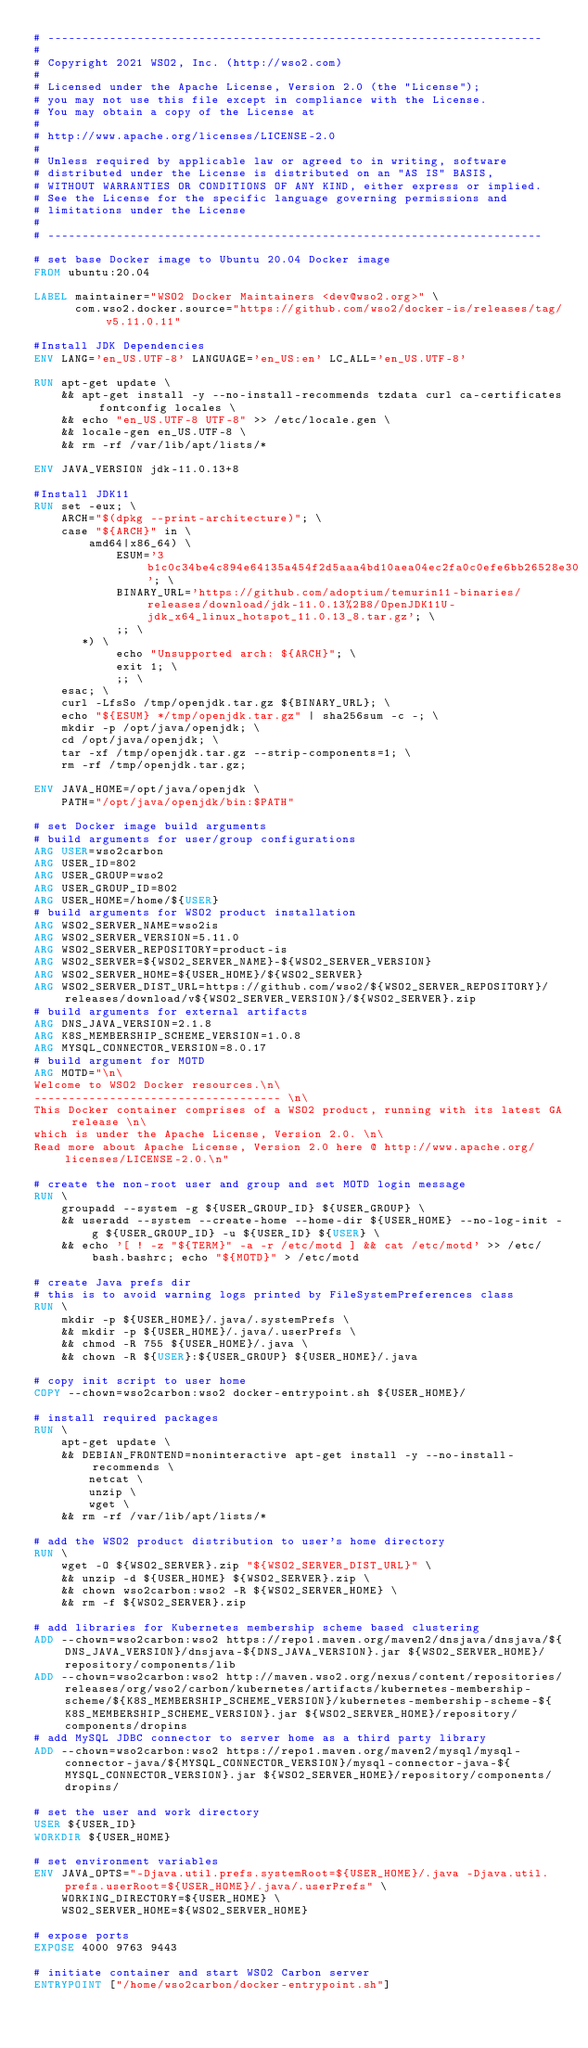Convert code to text. <code><loc_0><loc_0><loc_500><loc_500><_Dockerfile_># ------------------------------------------------------------------------
#
# Copyright 2021 WSO2, Inc. (http://wso2.com)
#
# Licensed under the Apache License, Version 2.0 (the "License");
# you may not use this file except in compliance with the License.
# You may obtain a copy of the License at
#
# http://www.apache.org/licenses/LICENSE-2.0
#
# Unless required by applicable law or agreed to in writing, software
# distributed under the License is distributed on an "AS IS" BASIS,
# WITHOUT WARRANTIES OR CONDITIONS OF ANY KIND, either express or implied.
# See the License for the specific language governing permissions and
# limitations under the License
#
# ------------------------------------------------------------------------

# set base Docker image to Ubuntu 20.04 Docker image
FROM ubuntu:20.04

LABEL maintainer="WSO2 Docker Maintainers <dev@wso2.org>" \
      com.wso2.docker.source="https://github.com/wso2/docker-is/releases/tag/v5.11.0.11"

#Install JDK Dependencies
ENV LANG='en_US.UTF-8' LANGUAGE='en_US:en' LC_ALL='en_US.UTF-8'

RUN apt-get update \
    && apt-get install -y --no-install-recommends tzdata curl ca-certificates fontconfig locales \
    && echo "en_US.UTF-8 UTF-8" >> /etc/locale.gen \
    && locale-gen en_US.UTF-8 \
    && rm -rf /var/lib/apt/lists/*

ENV JAVA_VERSION jdk-11.0.13+8

#Install JDK11
RUN set -eux; \
    ARCH="$(dpkg --print-architecture)"; \
    case "${ARCH}" in \
        amd64|x86_64) \
            ESUM='3b1c0c34be4c894e64135a454f2d5aaa4bd10aea04ec2fa0c0efe6bb26528e30'; \
            BINARY_URL='https://github.com/adoptium/temurin11-binaries/releases/download/jdk-11.0.13%2B8/OpenJDK11U-jdk_x64_linux_hotspot_11.0.13_8.tar.gz'; \
            ;; \
       *) \
            echo "Unsupported arch: ${ARCH}"; \
            exit 1; \
            ;; \
    esac; \
    curl -LfsSo /tmp/openjdk.tar.gz ${BINARY_URL}; \
    echo "${ESUM} */tmp/openjdk.tar.gz" | sha256sum -c -; \
    mkdir -p /opt/java/openjdk; \
    cd /opt/java/openjdk; \
    tar -xf /tmp/openjdk.tar.gz --strip-components=1; \
    rm -rf /tmp/openjdk.tar.gz;

ENV JAVA_HOME=/opt/java/openjdk \
    PATH="/opt/java/openjdk/bin:$PATH"

# set Docker image build arguments
# build arguments for user/group configurations
ARG USER=wso2carbon
ARG USER_ID=802
ARG USER_GROUP=wso2
ARG USER_GROUP_ID=802
ARG USER_HOME=/home/${USER}
# build arguments for WSO2 product installation
ARG WSO2_SERVER_NAME=wso2is
ARG WSO2_SERVER_VERSION=5.11.0
ARG WSO2_SERVER_REPOSITORY=product-is
ARG WSO2_SERVER=${WSO2_SERVER_NAME}-${WSO2_SERVER_VERSION}
ARG WSO2_SERVER_HOME=${USER_HOME}/${WSO2_SERVER}
ARG WSO2_SERVER_DIST_URL=https://github.com/wso2/${WSO2_SERVER_REPOSITORY}/releases/download/v${WSO2_SERVER_VERSION}/${WSO2_SERVER}.zip
# build arguments for external artifacts
ARG DNS_JAVA_VERSION=2.1.8
ARG K8S_MEMBERSHIP_SCHEME_VERSION=1.0.8
ARG MYSQL_CONNECTOR_VERSION=8.0.17
# build argument for MOTD
ARG MOTD="\n\
Welcome to WSO2 Docker resources.\n\
------------------------------------ \n\
This Docker container comprises of a WSO2 product, running with its latest GA release \n\
which is under the Apache License, Version 2.0. \n\
Read more about Apache License, Version 2.0 here @ http://www.apache.org/licenses/LICENSE-2.0.\n"

# create the non-root user and group and set MOTD login message
RUN \
    groupadd --system -g ${USER_GROUP_ID} ${USER_GROUP} \
    && useradd --system --create-home --home-dir ${USER_HOME} --no-log-init -g ${USER_GROUP_ID} -u ${USER_ID} ${USER} \
    && echo '[ ! -z "${TERM}" -a -r /etc/motd ] && cat /etc/motd' >> /etc/bash.bashrc; echo "${MOTD}" > /etc/motd

# create Java prefs dir
# this is to avoid warning logs printed by FileSystemPreferences class
RUN \
    mkdir -p ${USER_HOME}/.java/.systemPrefs \
    && mkdir -p ${USER_HOME}/.java/.userPrefs \
    && chmod -R 755 ${USER_HOME}/.java \
    && chown -R ${USER}:${USER_GROUP} ${USER_HOME}/.java

# copy init script to user home
COPY --chown=wso2carbon:wso2 docker-entrypoint.sh ${USER_HOME}/

# install required packages
RUN \
    apt-get update \
    && DEBIAN_FRONTEND=noninteractive apt-get install -y --no-install-recommends \
        netcat \
        unzip \
        wget \
    && rm -rf /var/lib/apt/lists/*

# add the WSO2 product distribution to user's home directory
RUN \
    wget -O ${WSO2_SERVER}.zip "${WSO2_SERVER_DIST_URL}" \
    && unzip -d ${USER_HOME} ${WSO2_SERVER}.zip \
    && chown wso2carbon:wso2 -R ${WSO2_SERVER_HOME} \
    && rm -f ${WSO2_SERVER}.zip

# add libraries for Kubernetes membership scheme based clustering
ADD --chown=wso2carbon:wso2 https://repo1.maven.org/maven2/dnsjava/dnsjava/${DNS_JAVA_VERSION}/dnsjava-${DNS_JAVA_VERSION}.jar ${WSO2_SERVER_HOME}/repository/components/lib
ADD --chown=wso2carbon:wso2 http://maven.wso2.org/nexus/content/repositories/releases/org/wso2/carbon/kubernetes/artifacts/kubernetes-membership-scheme/${K8S_MEMBERSHIP_SCHEME_VERSION}/kubernetes-membership-scheme-${K8S_MEMBERSHIP_SCHEME_VERSION}.jar ${WSO2_SERVER_HOME}/repository/components/dropins
# add MySQL JDBC connector to server home as a third party library
ADD --chown=wso2carbon:wso2 https://repo1.maven.org/maven2/mysql/mysql-connector-java/${MYSQL_CONNECTOR_VERSION}/mysql-connector-java-${MYSQL_CONNECTOR_VERSION}.jar ${WSO2_SERVER_HOME}/repository/components/dropins/

# set the user and work directory
USER ${USER_ID}
WORKDIR ${USER_HOME}

# set environment variables
ENV JAVA_OPTS="-Djava.util.prefs.systemRoot=${USER_HOME}/.java -Djava.util.prefs.userRoot=${USER_HOME}/.java/.userPrefs" \
    WORKING_DIRECTORY=${USER_HOME} \
    WSO2_SERVER_HOME=${WSO2_SERVER_HOME}

# expose ports
EXPOSE 4000 9763 9443

# initiate container and start WSO2 Carbon server
ENTRYPOINT ["/home/wso2carbon/docker-entrypoint.sh"]
</code> 